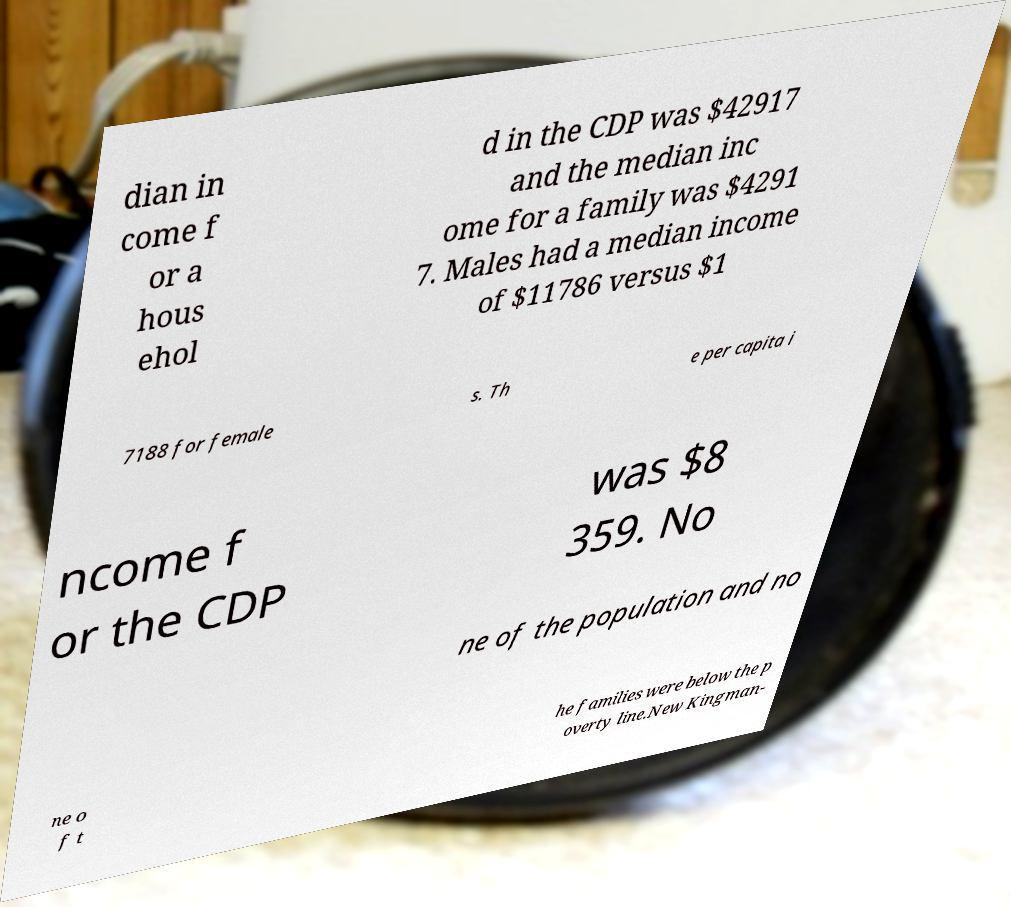Could you assist in decoding the text presented in this image and type it out clearly? dian in come f or a hous ehol d in the CDP was $42917 and the median inc ome for a family was $4291 7. Males had a median income of $11786 versus $1 7188 for female s. Th e per capita i ncome f or the CDP was $8 359. No ne of the population and no ne o f t he families were below the p overty line.New Kingman- 